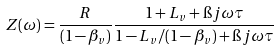<formula> <loc_0><loc_0><loc_500><loc_500>Z ( \omega ) = \frac { R } { ( 1 - \beta _ { v } ) } \frac { 1 + L _ { v } + \i j \omega \tau } { 1 - L _ { v } / ( 1 - \beta _ { v } ) + \i j \omega \tau }</formula> 